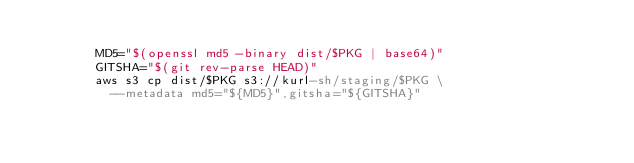Convert code to text. <code><loc_0><loc_0><loc_500><loc_500><_YAML_>
        MD5="$(openssl md5 -binary dist/$PKG | base64)"
        GITSHA="$(git rev-parse HEAD)"
        aws s3 cp dist/$PKG s3://kurl-sh/staging/$PKG \
          --metadata md5="${MD5}",gitsha="${GITSHA}"
</code> 